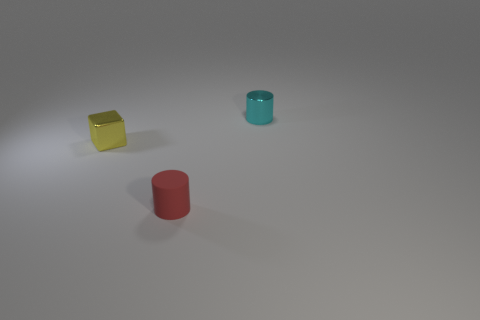There is a cyan cylinder; how many red rubber objects are in front of it?
Provide a succinct answer. 1. Are there any cyan cylinders made of the same material as the tiny yellow thing?
Your answer should be very brief. Yes. There is a small cylinder that is behind the small red matte thing; what is its color?
Keep it short and to the point. Cyan. Is the number of small metal objects to the left of the matte cylinder the same as the number of tiny cyan metal cylinders in front of the yellow shiny block?
Provide a succinct answer. No. What material is the small cylinder on the left side of the tiny cylinder that is behind the tiny yellow object made of?
Keep it short and to the point. Rubber. What number of things are either red objects or small metallic things in front of the small cyan thing?
Your answer should be very brief. 2. Are there more small cyan cylinders that are behind the yellow block than big yellow metal things?
Provide a short and direct response. Yes. There is a cyan thing that is the same shape as the small red object; what material is it?
Your answer should be very brief. Metal. There is a shiny object left of the cyan metallic cylinder; is its size the same as the cyan object?
Give a very brief answer. Yes. There is a thing that is behind the small red cylinder and on the left side of the small shiny cylinder; what color is it?
Your answer should be very brief. Yellow. 